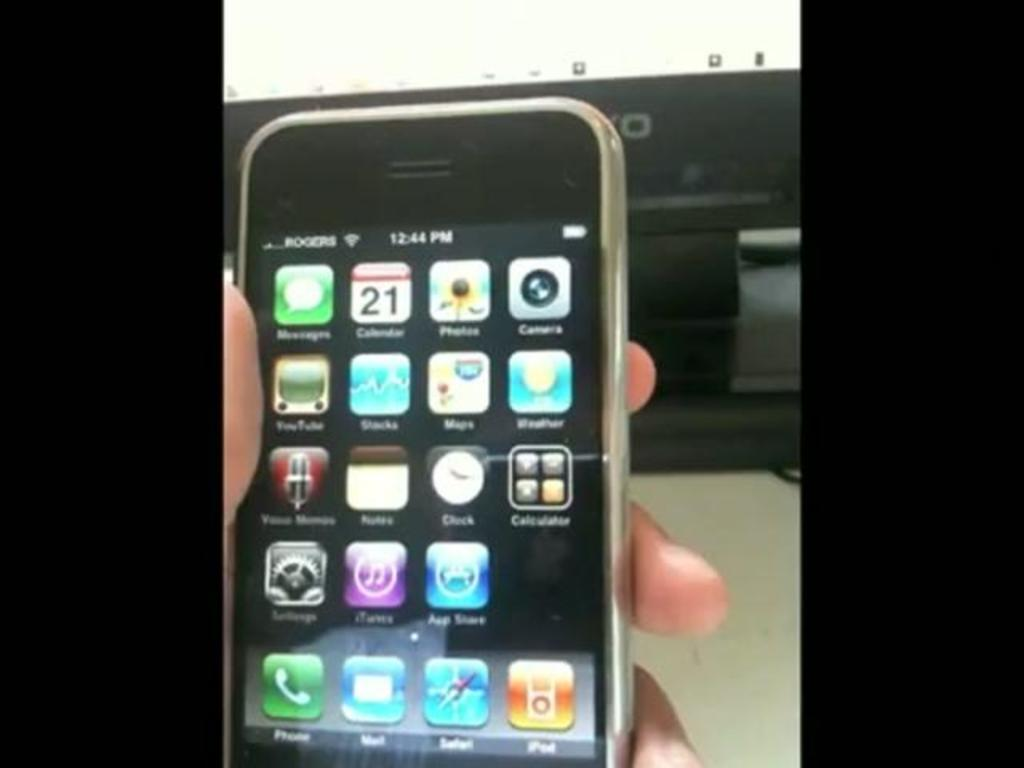<image>
Relay a brief, clear account of the picture shown. Someone is holding a smartphone in one hand displaying different apps and showing the time as 12:44 PM. 